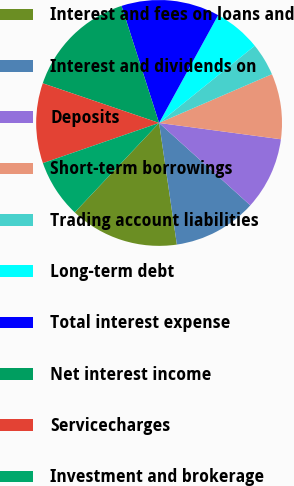Convert chart. <chart><loc_0><loc_0><loc_500><loc_500><pie_chart><fcel>Interest and fees on loans and<fcel>Interest and dividends on<fcel>Deposits<fcel>Short-term borrowings<fcel>Trading account liabilities<fcel>Long-term debt<fcel>Total interest expense<fcel>Net interest income<fcel>Servicecharges<fcel>Investment and brokerage<nl><fcel>14.35%<fcel>11.0%<fcel>9.57%<fcel>8.61%<fcel>4.31%<fcel>6.22%<fcel>12.92%<fcel>14.83%<fcel>10.53%<fcel>7.66%<nl></chart> 